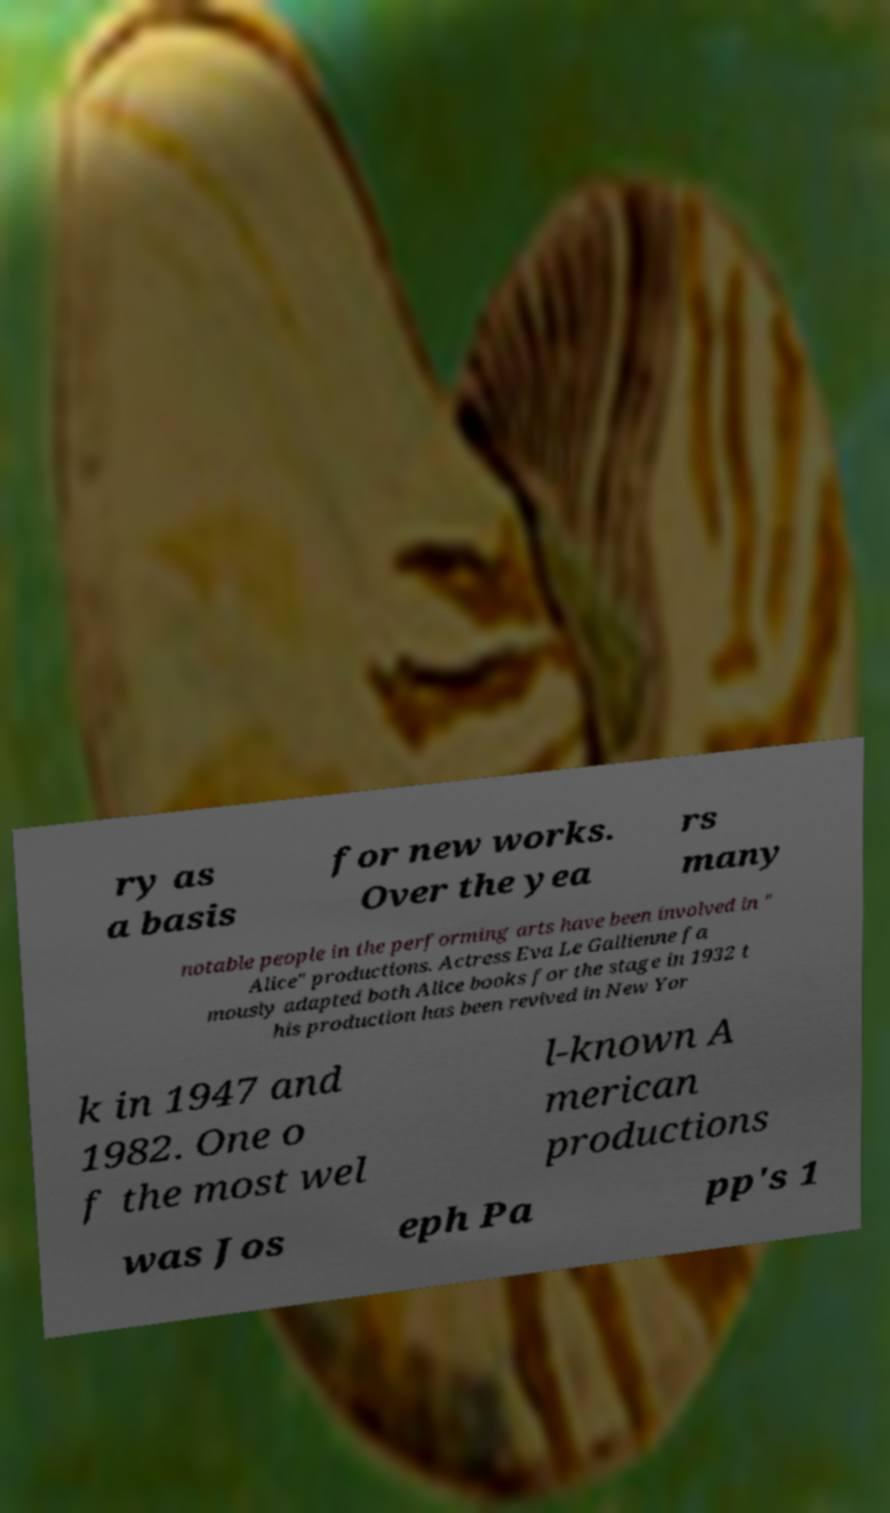I need the written content from this picture converted into text. Can you do that? ry as a basis for new works. Over the yea rs many notable people in the performing arts have been involved in " Alice" productions. Actress Eva Le Gallienne fa mously adapted both Alice books for the stage in 1932 t his production has been revived in New Yor k in 1947 and 1982. One o f the most wel l-known A merican productions was Jos eph Pa pp's 1 